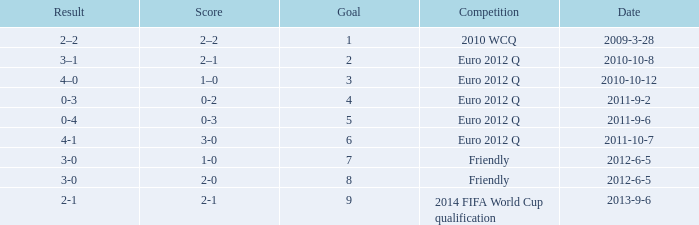How many goals when the score is 3-0 in the euro 2012 q? 1.0. 